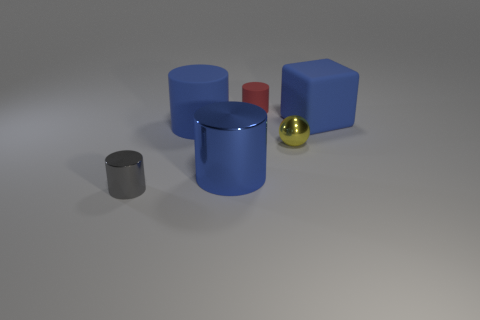Do the rubber object left of the tiny red cylinder and the ball that is to the right of the red rubber cylinder have the same size?
Ensure brevity in your answer.  No. How many objects are objects that are left of the tiny matte cylinder or blue objects to the right of the big blue metal cylinder?
Offer a terse response. 4. Is there any other thing that has the same shape as the small yellow metal thing?
Your answer should be compact. No. There is a big matte thing in front of the big blue block; is its color the same as the shiny cylinder that is behind the small gray shiny object?
Offer a terse response. Yes. How many rubber objects are either large blue cylinders or small green objects?
Your answer should be compact. 1. The small red rubber thing that is on the right side of the metal cylinder that is in front of the large blue metal thing is what shape?
Make the answer very short. Cylinder. Are the big blue block on the right side of the tiny red matte thing and the red thing behind the big blue shiny cylinder made of the same material?
Provide a short and direct response. Yes. How many blue objects are in front of the large blue object that is to the right of the tiny matte object?
Keep it short and to the point. 2. Is the shape of the big blue rubber thing to the left of the red object the same as the gray metal thing that is to the left of the big blue matte cylinder?
Your answer should be very brief. Yes. What size is the rubber object that is both in front of the red cylinder and left of the large blue block?
Give a very brief answer. Large. 